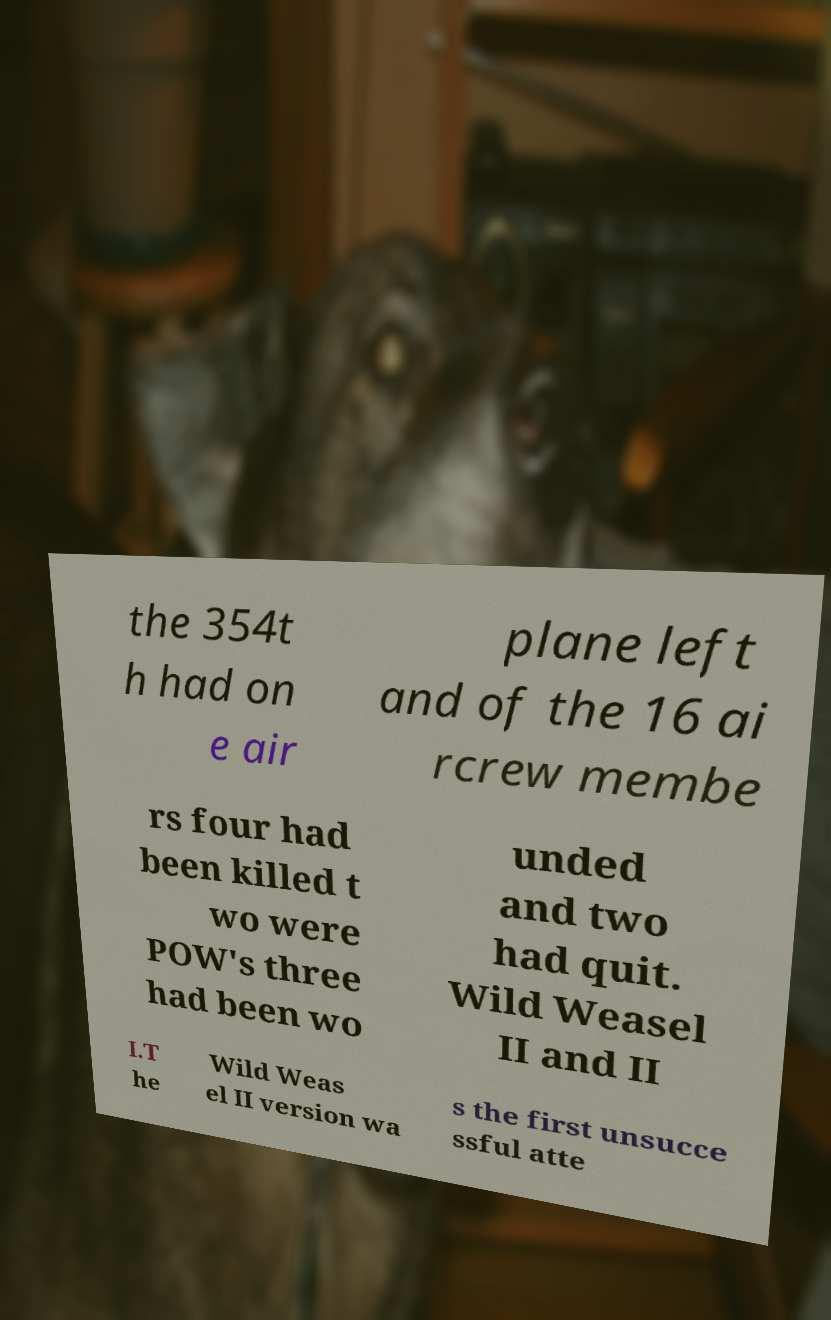There's text embedded in this image that I need extracted. Can you transcribe it verbatim? the 354t h had on e air plane left and of the 16 ai rcrew membe rs four had been killed t wo were POW's three had been wo unded and two had quit. Wild Weasel II and II I.T he Wild Weas el II version wa s the first unsucce ssful atte 